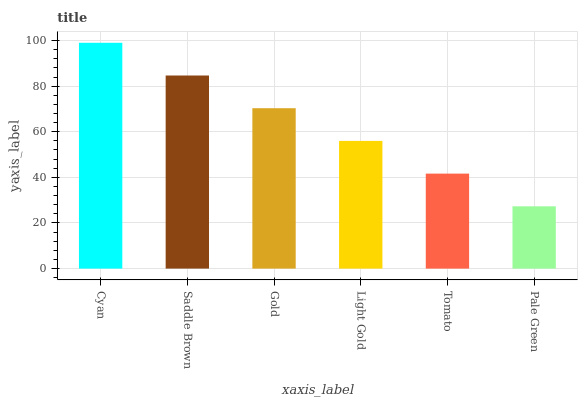Is Saddle Brown the minimum?
Answer yes or no. No. Is Saddle Brown the maximum?
Answer yes or no. No. Is Cyan greater than Saddle Brown?
Answer yes or no. Yes. Is Saddle Brown less than Cyan?
Answer yes or no. Yes. Is Saddle Brown greater than Cyan?
Answer yes or no. No. Is Cyan less than Saddle Brown?
Answer yes or no. No. Is Gold the high median?
Answer yes or no. Yes. Is Light Gold the low median?
Answer yes or no. Yes. Is Pale Green the high median?
Answer yes or no. No. Is Saddle Brown the low median?
Answer yes or no. No. 